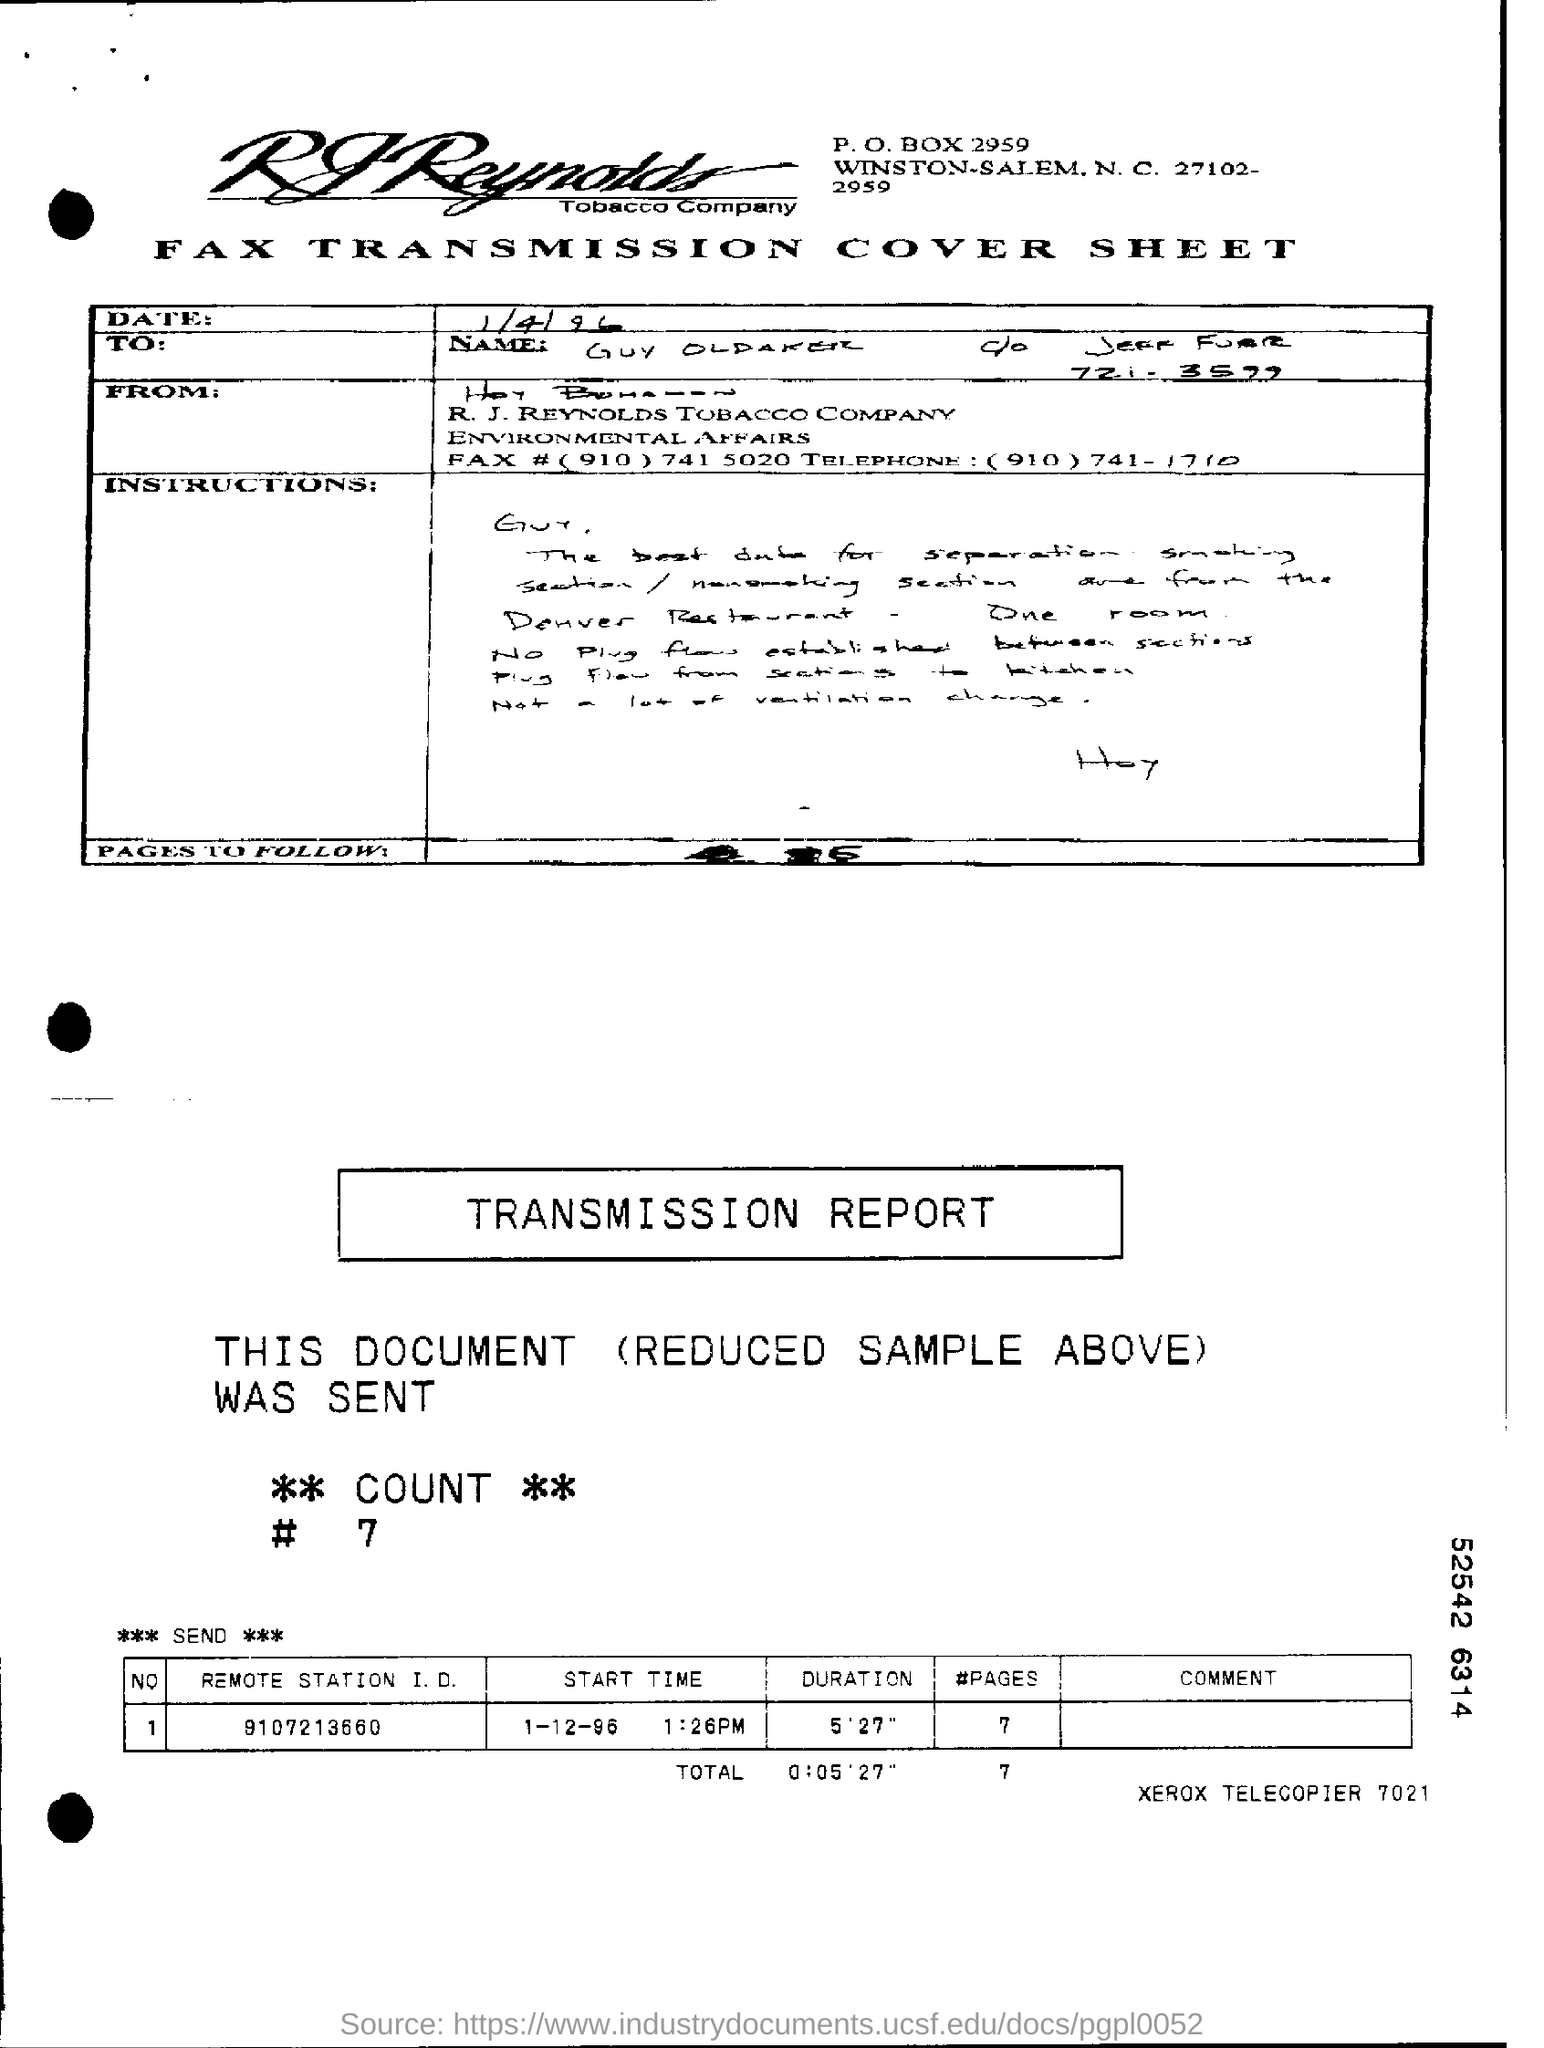What is the PO Box number of the company?
Make the answer very short. 2959. What is the remote station i.d?
Offer a terse response. 9107213660. What is the date on which transmission was made?
Provide a succinct answer. 1-12-96. 